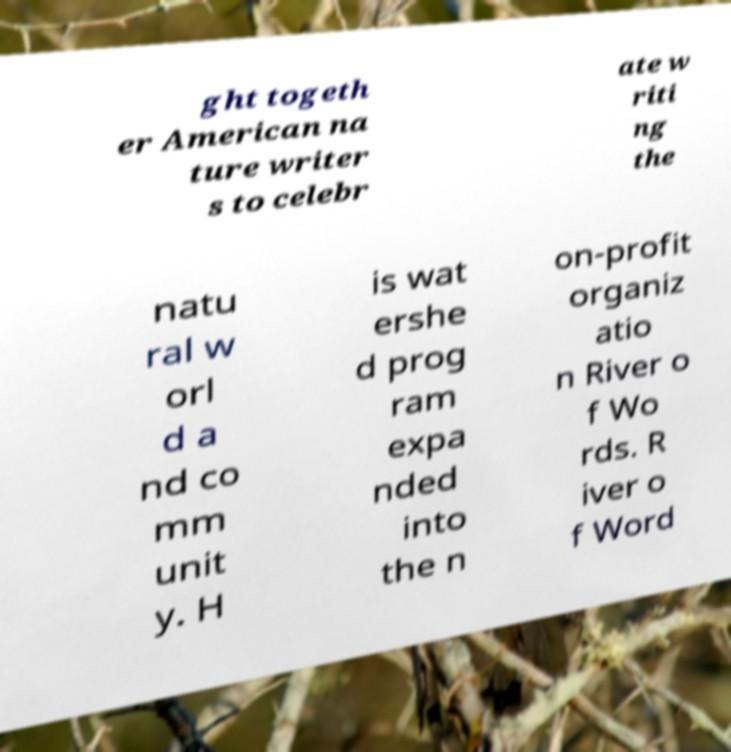Can you read and provide the text displayed in the image?This photo seems to have some interesting text. Can you extract and type it out for me? ght togeth er American na ture writer s to celebr ate w riti ng the natu ral w orl d a nd co mm unit y. H is wat ershe d prog ram expa nded into the n on-profit organiz atio n River o f Wo rds. R iver o f Word 